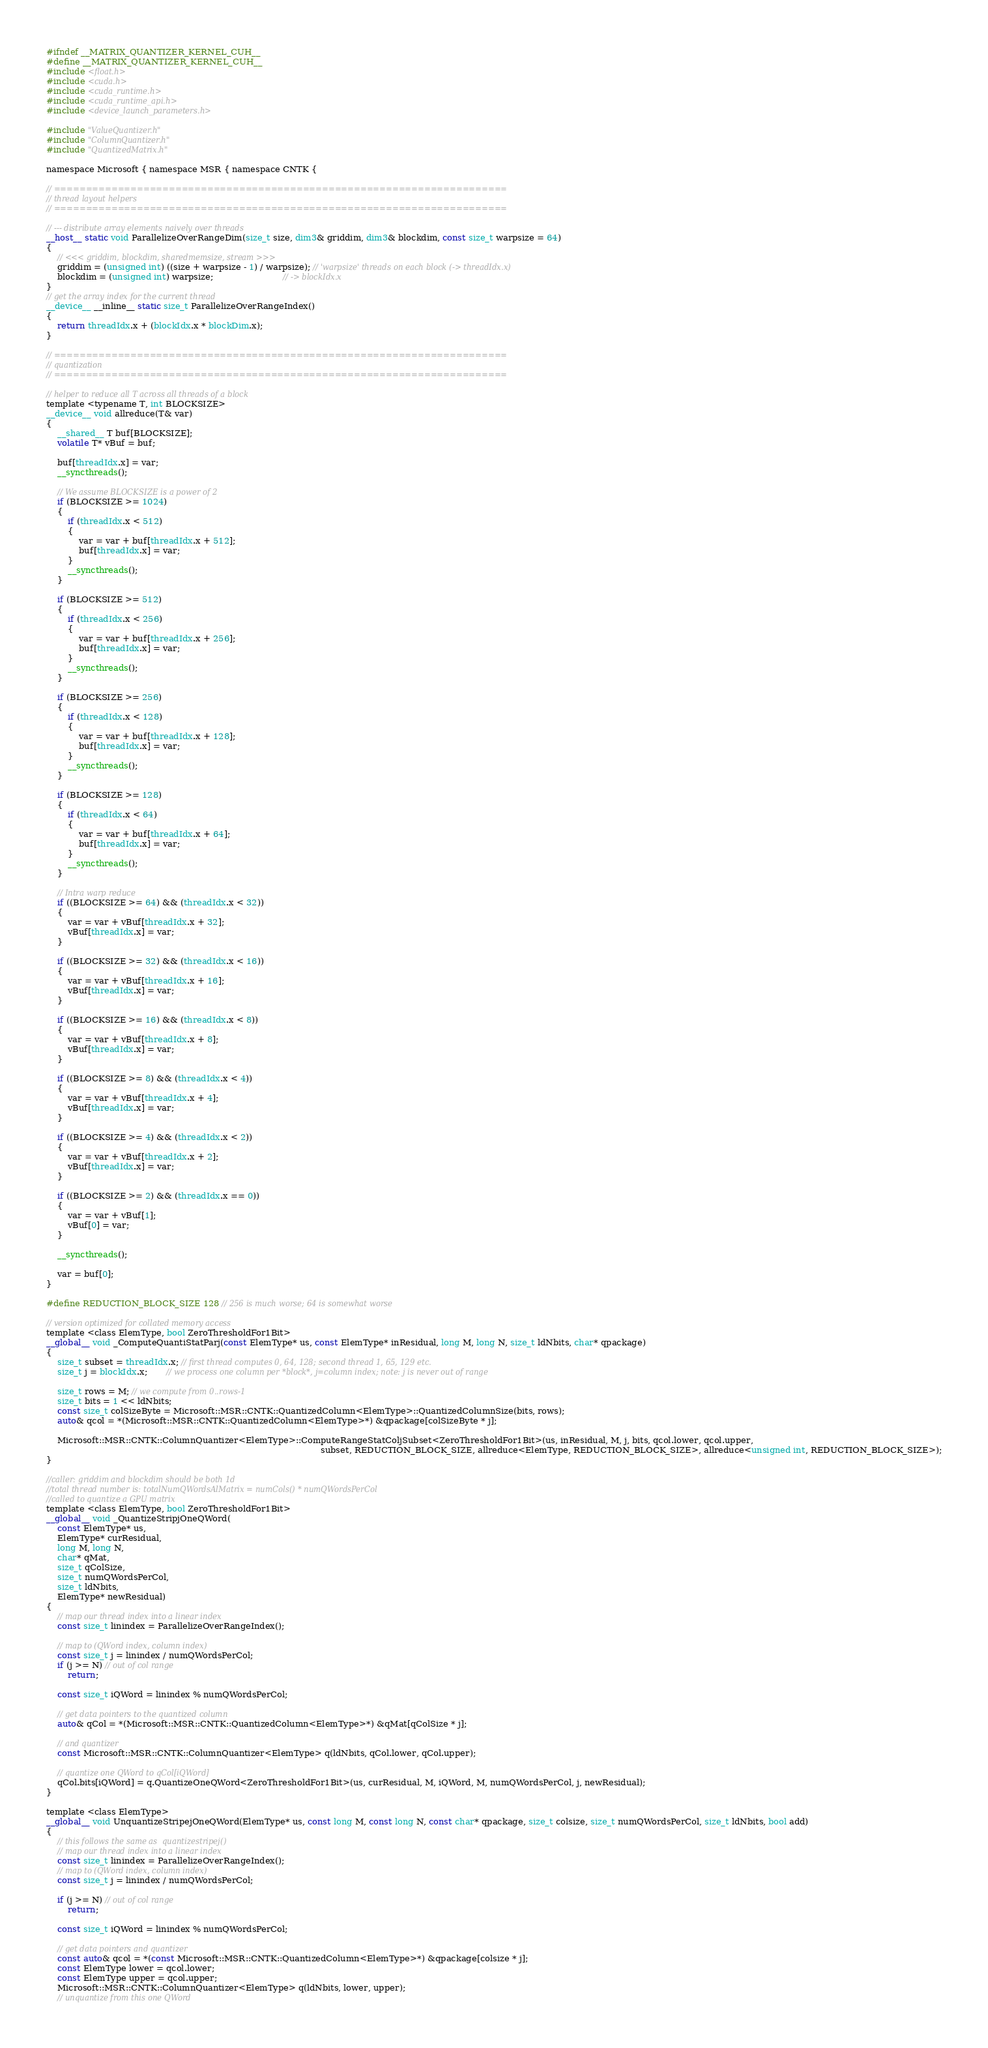Convert code to text. <code><loc_0><loc_0><loc_500><loc_500><_Cuda_>#ifndef __MATRIX_QUANTIZER_KERNEL_CUH__
#define __MATRIX_QUANTIZER_KERNEL_CUH__
#include <float.h>
#include <cuda.h>
#include <cuda_runtime.h>
#include <cuda_runtime_api.h>
#include <device_launch_parameters.h>

#include "ValueQuantizer.h"
#include "ColumnQuantizer.h"
#include "QuantizedMatrix.h"

namespace Microsoft { namespace MSR { namespace CNTK {

// =======================================================================
// thread layout helpers
// =======================================================================

// --- distribute array elements naively over threads
__host__ static void ParallelizeOverRangeDim(size_t size, dim3& griddim, dim3& blockdim, const size_t warpsize = 64)
{
    // <<< griddim, blockdim, sharedmemsize, stream >>>
    griddim = (unsigned int) ((size + warpsize - 1) / warpsize); // 'warpsize' threads on each block (-> threadIdx.x)
    blockdim = (unsigned int) warpsize;                          // -> blockIdx.x
}
// get the array index for the current thread
__device__ __inline__ static size_t ParallelizeOverRangeIndex()
{
    return threadIdx.x + (blockIdx.x * blockDim.x);
}

// =======================================================================
// quantization
// =======================================================================

// helper to reduce all T across all threads of a block
template <typename T, int BLOCKSIZE>
__device__ void allreduce(T& var)
{
    __shared__ T buf[BLOCKSIZE];
    volatile T* vBuf = buf;

    buf[threadIdx.x] = var;
    __syncthreads();

    // We assume BLOCKSIZE is a power of 2
    if (BLOCKSIZE >= 1024)
    {
        if (threadIdx.x < 512)
        {
            var = var + buf[threadIdx.x + 512];
            buf[threadIdx.x] = var;
        }
        __syncthreads();
    }

    if (BLOCKSIZE >= 512)
    {
        if (threadIdx.x < 256)
        {
            var = var + buf[threadIdx.x + 256];
            buf[threadIdx.x] = var;
        }
        __syncthreads();
    }

    if (BLOCKSIZE >= 256)
    {
        if (threadIdx.x < 128)
        {
            var = var + buf[threadIdx.x + 128];
            buf[threadIdx.x] = var;
        }
        __syncthreads();
    }

    if (BLOCKSIZE >= 128)
    {
        if (threadIdx.x < 64)
        {
            var = var + buf[threadIdx.x + 64];
            buf[threadIdx.x] = var;
        }
        __syncthreads();
    }

    // Intra warp reduce
    if ((BLOCKSIZE >= 64) && (threadIdx.x < 32))
    {
        var = var + vBuf[threadIdx.x + 32];
        vBuf[threadIdx.x] = var;
    }

    if ((BLOCKSIZE >= 32) && (threadIdx.x < 16))
    {
        var = var + vBuf[threadIdx.x + 16];
        vBuf[threadIdx.x] = var;
    }

    if ((BLOCKSIZE >= 16) && (threadIdx.x < 8))
    {
        var = var + vBuf[threadIdx.x + 8];
        vBuf[threadIdx.x] = var;
    }

    if ((BLOCKSIZE >= 8) && (threadIdx.x < 4))
    {
        var = var + vBuf[threadIdx.x + 4];
        vBuf[threadIdx.x] = var;
    }

    if ((BLOCKSIZE >= 4) && (threadIdx.x < 2))
    {
        var = var + vBuf[threadIdx.x + 2];
        vBuf[threadIdx.x] = var;
    }

    if ((BLOCKSIZE >= 2) && (threadIdx.x == 0))
    {
        var = var + vBuf[1];
        vBuf[0] = var;
    }

    __syncthreads();

    var = buf[0];
}

#define REDUCTION_BLOCK_SIZE 128 // 256 is much worse; 64 is somewhat worse

// version optimized for collated memory access
template <class ElemType, bool ZeroThresholdFor1Bit>
__global__ void _ComputeQuantiStatParj(const ElemType* us, const ElemType* inResidual, long M, long N, size_t ldNbits, char* qpackage)
{
    size_t subset = threadIdx.x; // first thread computes 0, 64, 128; second thread 1, 65, 129 etc.
    size_t j = blockIdx.x;       // we process one column per *block*, j=column index; note: j is never out of range

    size_t rows = M; // we compute from 0..rows-1
    size_t bits = 1 << ldNbits;
    const size_t colSizeByte = Microsoft::MSR::CNTK::QuantizedColumn<ElemType>::QuantizedColumnSize(bits, rows);
    auto& qcol = *(Microsoft::MSR::CNTK::QuantizedColumn<ElemType>*) &qpackage[colSizeByte * j];

    Microsoft::MSR::CNTK::ColumnQuantizer<ElemType>::ComputeRangeStatColjSubset<ZeroThresholdFor1Bit>(us, inResidual, M, j, bits, qcol.lower, qcol.upper,
                                                                                                      subset, REDUCTION_BLOCK_SIZE, allreduce<ElemType, REDUCTION_BLOCK_SIZE>, allreduce<unsigned int, REDUCTION_BLOCK_SIZE>);
}

//caller: griddim and blockdim should be both 1d
//total thread number is: totalNumQWordsAlMatrix = numCols() * numQWordsPerCol
//called to quantize a GPU matrix
template <class ElemType, bool ZeroThresholdFor1Bit>
__global__ void _QuantizeStripjOneQWord(
    const ElemType* us,
    ElemType* curResidual,
    long M, long N,
    char* qMat,
    size_t qColSize,
    size_t numQWordsPerCol,
    size_t ldNbits,
    ElemType* newResidual)
{
    // map our thread index into a linear index
    const size_t linindex = ParallelizeOverRangeIndex();

    // map to (QWord index, column index)
    const size_t j = linindex / numQWordsPerCol;
    if (j >= N) // out of col range
        return;

    const size_t iQWord = linindex % numQWordsPerCol;

    // get data pointers to the quantized column
    auto& qCol = *(Microsoft::MSR::CNTK::QuantizedColumn<ElemType>*) &qMat[qColSize * j];

    // and quantizer
    const Microsoft::MSR::CNTK::ColumnQuantizer<ElemType> q(ldNbits, qCol.lower, qCol.upper);

    // quantize one QWord to qCol[iQWord]
    qCol.bits[iQWord] = q.QuantizeOneQWord<ZeroThresholdFor1Bit>(us, curResidual, M, iQWord, M, numQWordsPerCol, j, newResidual);
}

template <class ElemType>
__global__ void UnquantizeStripejOneQWord(ElemType* us, const long M, const long N, const char* qpackage, size_t colsize, size_t numQWordsPerCol, size_t ldNbits, bool add)
{
    // this follows the same as  quantizestripej()
    // map our thread index into a linear index
    const size_t linindex = ParallelizeOverRangeIndex();
    // map to (QWord index, column index)
    const size_t j = linindex / numQWordsPerCol;

    if (j >= N) // out of col range
        return;

    const size_t iQWord = linindex % numQWordsPerCol;

    // get data pointers and quantizer
    const auto& qcol = *(const Microsoft::MSR::CNTK::QuantizedColumn<ElemType>*) &qpackage[colsize * j];
    const ElemType lower = qcol.lower;
    const ElemType upper = qcol.upper;
    Microsoft::MSR::CNTK::ColumnQuantizer<ElemType> q(ldNbits, lower, upper);
    // unquantize from this one QWord</code> 